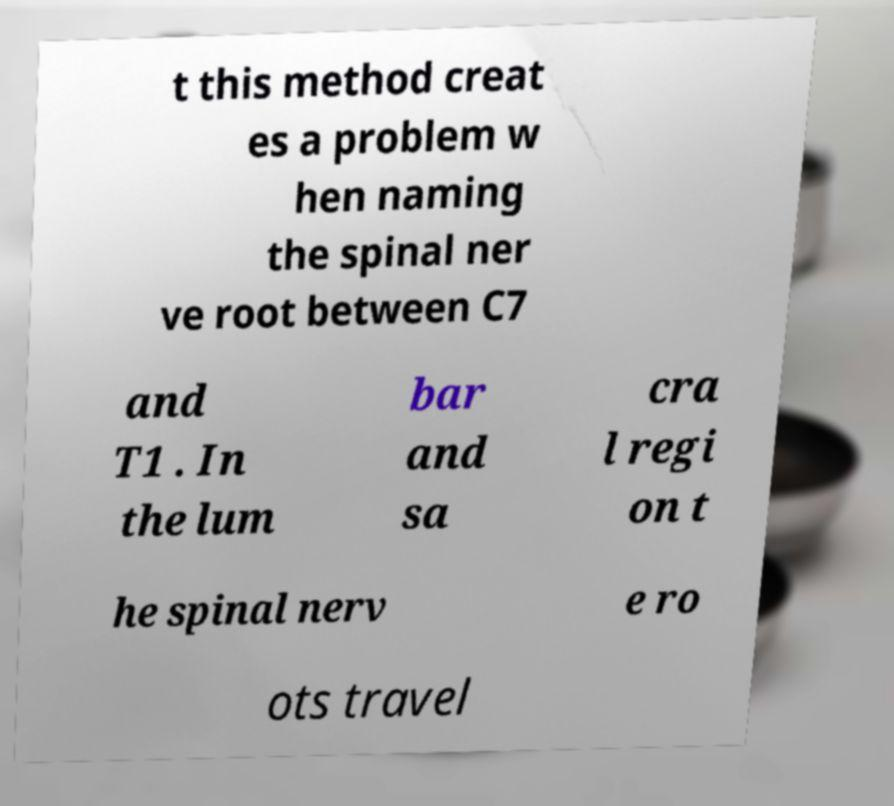I need the written content from this picture converted into text. Can you do that? t this method creat es a problem w hen naming the spinal ner ve root between C7 and T1 . In the lum bar and sa cra l regi on t he spinal nerv e ro ots travel 